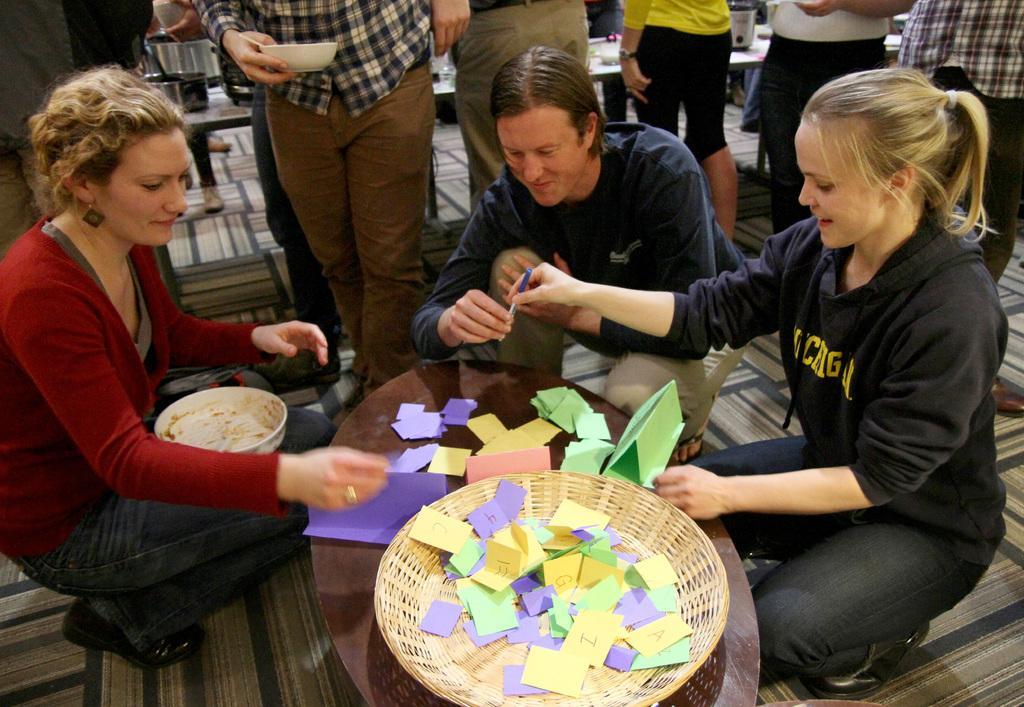How would you summarize this image in a sentence or two? In this picture there are two persons holding a pen in their hands and there is another person carrying a bowl on her laps in front of them and there is a table in between them and which has few color papers and something written on it and there are few other persons standing in the background. 